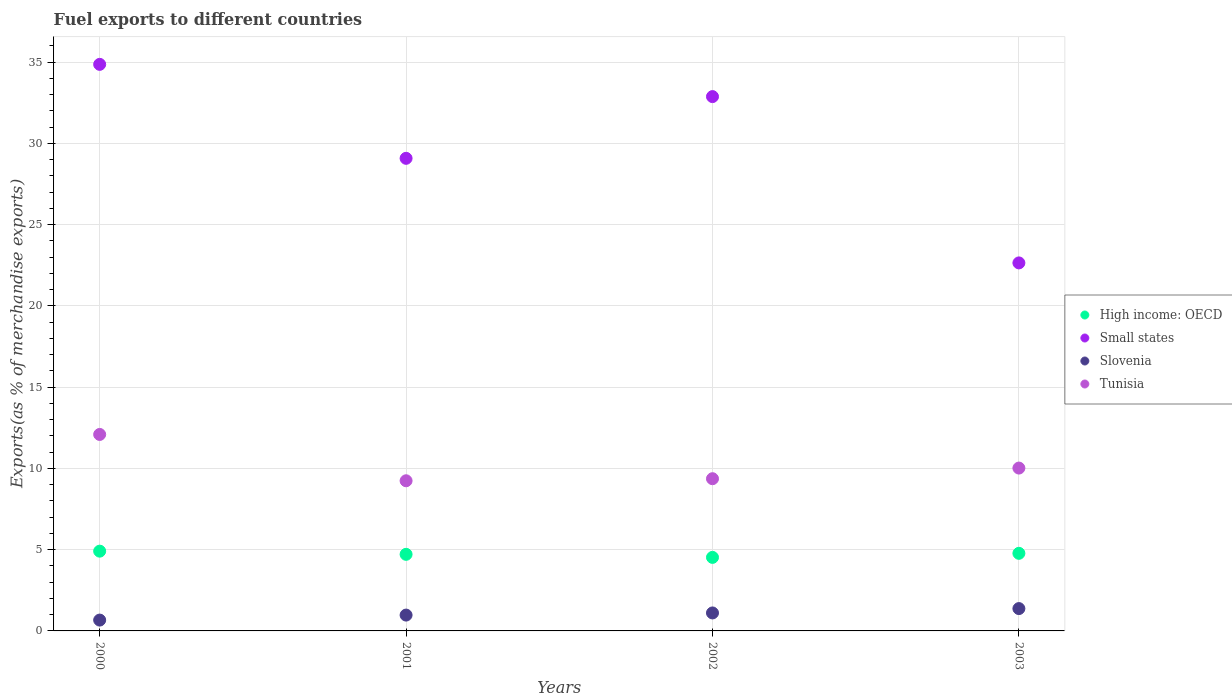Is the number of dotlines equal to the number of legend labels?
Keep it short and to the point. Yes. What is the percentage of exports to different countries in Small states in 2001?
Offer a terse response. 29.08. Across all years, what is the maximum percentage of exports to different countries in Slovenia?
Offer a very short reply. 1.37. Across all years, what is the minimum percentage of exports to different countries in High income: OECD?
Your answer should be compact. 4.52. In which year was the percentage of exports to different countries in High income: OECD maximum?
Offer a very short reply. 2000. What is the total percentage of exports to different countries in Tunisia in the graph?
Your answer should be compact. 40.71. What is the difference between the percentage of exports to different countries in High income: OECD in 2000 and that in 2002?
Ensure brevity in your answer.  0.38. What is the difference between the percentage of exports to different countries in Slovenia in 2001 and the percentage of exports to different countries in Small states in 2000?
Provide a succinct answer. -33.89. What is the average percentage of exports to different countries in Slovenia per year?
Offer a terse response. 1.03. In the year 2003, what is the difference between the percentage of exports to different countries in Tunisia and percentage of exports to different countries in Small states?
Provide a short and direct response. -12.62. What is the ratio of the percentage of exports to different countries in Tunisia in 2000 to that in 2002?
Ensure brevity in your answer.  1.29. Is the difference between the percentage of exports to different countries in Tunisia in 2000 and 2002 greater than the difference between the percentage of exports to different countries in Small states in 2000 and 2002?
Keep it short and to the point. Yes. What is the difference between the highest and the second highest percentage of exports to different countries in Tunisia?
Keep it short and to the point. 2.07. What is the difference between the highest and the lowest percentage of exports to different countries in Small states?
Ensure brevity in your answer.  12.22. In how many years, is the percentage of exports to different countries in High income: OECD greater than the average percentage of exports to different countries in High income: OECD taken over all years?
Make the answer very short. 2. Is the sum of the percentage of exports to different countries in Slovenia in 2002 and 2003 greater than the maximum percentage of exports to different countries in High income: OECD across all years?
Your answer should be very brief. No. Is it the case that in every year, the sum of the percentage of exports to different countries in Small states and percentage of exports to different countries in Tunisia  is greater than the sum of percentage of exports to different countries in High income: OECD and percentage of exports to different countries in Slovenia?
Your answer should be compact. No. Is it the case that in every year, the sum of the percentage of exports to different countries in Slovenia and percentage of exports to different countries in Tunisia  is greater than the percentage of exports to different countries in High income: OECD?
Your response must be concise. Yes. Does the percentage of exports to different countries in Small states monotonically increase over the years?
Your response must be concise. No. Is the percentage of exports to different countries in Small states strictly less than the percentage of exports to different countries in Slovenia over the years?
Make the answer very short. No. How many dotlines are there?
Provide a short and direct response. 4. How many years are there in the graph?
Make the answer very short. 4. What is the difference between two consecutive major ticks on the Y-axis?
Your response must be concise. 5. Where does the legend appear in the graph?
Keep it short and to the point. Center right. How many legend labels are there?
Offer a terse response. 4. What is the title of the graph?
Provide a succinct answer. Fuel exports to different countries. What is the label or title of the X-axis?
Your answer should be compact. Years. What is the label or title of the Y-axis?
Your answer should be very brief. Exports(as % of merchandise exports). What is the Exports(as % of merchandise exports) in High income: OECD in 2000?
Your answer should be compact. 4.91. What is the Exports(as % of merchandise exports) in Small states in 2000?
Give a very brief answer. 34.86. What is the Exports(as % of merchandise exports) of Slovenia in 2000?
Offer a very short reply. 0.67. What is the Exports(as % of merchandise exports) in Tunisia in 2000?
Make the answer very short. 12.09. What is the Exports(as % of merchandise exports) of High income: OECD in 2001?
Provide a short and direct response. 4.71. What is the Exports(as % of merchandise exports) of Small states in 2001?
Offer a terse response. 29.08. What is the Exports(as % of merchandise exports) in Slovenia in 2001?
Your answer should be very brief. 0.97. What is the Exports(as % of merchandise exports) in Tunisia in 2001?
Your response must be concise. 9.24. What is the Exports(as % of merchandise exports) in High income: OECD in 2002?
Your answer should be compact. 4.52. What is the Exports(as % of merchandise exports) of Small states in 2002?
Give a very brief answer. 32.88. What is the Exports(as % of merchandise exports) of Slovenia in 2002?
Keep it short and to the point. 1.11. What is the Exports(as % of merchandise exports) of Tunisia in 2002?
Ensure brevity in your answer.  9.36. What is the Exports(as % of merchandise exports) in High income: OECD in 2003?
Offer a very short reply. 4.77. What is the Exports(as % of merchandise exports) in Small states in 2003?
Your answer should be very brief. 22.64. What is the Exports(as % of merchandise exports) in Slovenia in 2003?
Make the answer very short. 1.37. What is the Exports(as % of merchandise exports) in Tunisia in 2003?
Your answer should be very brief. 10.02. Across all years, what is the maximum Exports(as % of merchandise exports) of High income: OECD?
Offer a very short reply. 4.91. Across all years, what is the maximum Exports(as % of merchandise exports) of Small states?
Your response must be concise. 34.86. Across all years, what is the maximum Exports(as % of merchandise exports) in Slovenia?
Your answer should be very brief. 1.37. Across all years, what is the maximum Exports(as % of merchandise exports) of Tunisia?
Provide a succinct answer. 12.09. Across all years, what is the minimum Exports(as % of merchandise exports) of High income: OECD?
Offer a very short reply. 4.52. Across all years, what is the minimum Exports(as % of merchandise exports) of Small states?
Your answer should be compact. 22.64. Across all years, what is the minimum Exports(as % of merchandise exports) of Slovenia?
Your answer should be very brief. 0.67. Across all years, what is the minimum Exports(as % of merchandise exports) of Tunisia?
Provide a succinct answer. 9.24. What is the total Exports(as % of merchandise exports) in High income: OECD in the graph?
Keep it short and to the point. 18.92. What is the total Exports(as % of merchandise exports) of Small states in the graph?
Provide a short and direct response. 119.46. What is the total Exports(as % of merchandise exports) in Slovenia in the graph?
Your answer should be compact. 4.12. What is the total Exports(as % of merchandise exports) of Tunisia in the graph?
Your response must be concise. 40.71. What is the difference between the Exports(as % of merchandise exports) of High income: OECD in 2000 and that in 2001?
Your answer should be very brief. 0.2. What is the difference between the Exports(as % of merchandise exports) in Small states in 2000 and that in 2001?
Keep it short and to the point. 5.78. What is the difference between the Exports(as % of merchandise exports) of Slovenia in 2000 and that in 2001?
Your answer should be very brief. -0.31. What is the difference between the Exports(as % of merchandise exports) of Tunisia in 2000 and that in 2001?
Your answer should be compact. 2.85. What is the difference between the Exports(as % of merchandise exports) of High income: OECD in 2000 and that in 2002?
Provide a succinct answer. 0.38. What is the difference between the Exports(as % of merchandise exports) of Small states in 2000 and that in 2002?
Your answer should be compact. 1.98. What is the difference between the Exports(as % of merchandise exports) of Slovenia in 2000 and that in 2002?
Make the answer very short. -0.44. What is the difference between the Exports(as % of merchandise exports) in Tunisia in 2000 and that in 2002?
Give a very brief answer. 2.72. What is the difference between the Exports(as % of merchandise exports) of High income: OECD in 2000 and that in 2003?
Make the answer very short. 0.13. What is the difference between the Exports(as % of merchandise exports) in Small states in 2000 and that in 2003?
Your response must be concise. 12.22. What is the difference between the Exports(as % of merchandise exports) in Slovenia in 2000 and that in 2003?
Keep it short and to the point. -0.71. What is the difference between the Exports(as % of merchandise exports) of Tunisia in 2000 and that in 2003?
Keep it short and to the point. 2.07. What is the difference between the Exports(as % of merchandise exports) in High income: OECD in 2001 and that in 2002?
Ensure brevity in your answer.  0.19. What is the difference between the Exports(as % of merchandise exports) in Small states in 2001 and that in 2002?
Offer a terse response. -3.8. What is the difference between the Exports(as % of merchandise exports) in Slovenia in 2001 and that in 2002?
Make the answer very short. -0.13. What is the difference between the Exports(as % of merchandise exports) of Tunisia in 2001 and that in 2002?
Your response must be concise. -0.13. What is the difference between the Exports(as % of merchandise exports) of High income: OECD in 2001 and that in 2003?
Offer a terse response. -0.06. What is the difference between the Exports(as % of merchandise exports) of Small states in 2001 and that in 2003?
Your answer should be very brief. 6.43. What is the difference between the Exports(as % of merchandise exports) in Slovenia in 2001 and that in 2003?
Keep it short and to the point. -0.4. What is the difference between the Exports(as % of merchandise exports) of Tunisia in 2001 and that in 2003?
Keep it short and to the point. -0.78. What is the difference between the Exports(as % of merchandise exports) of High income: OECD in 2002 and that in 2003?
Your answer should be compact. -0.25. What is the difference between the Exports(as % of merchandise exports) of Small states in 2002 and that in 2003?
Offer a very short reply. 10.23. What is the difference between the Exports(as % of merchandise exports) of Slovenia in 2002 and that in 2003?
Your response must be concise. -0.27. What is the difference between the Exports(as % of merchandise exports) of Tunisia in 2002 and that in 2003?
Give a very brief answer. -0.65. What is the difference between the Exports(as % of merchandise exports) in High income: OECD in 2000 and the Exports(as % of merchandise exports) in Small states in 2001?
Provide a short and direct response. -24.17. What is the difference between the Exports(as % of merchandise exports) in High income: OECD in 2000 and the Exports(as % of merchandise exports) in Slovenia in 2001?
Your answer should be very brief. 3.93. What is the difference between the Exports(as % of merchandise exports) in High income: OECD in 2000 and the Exports(as % of merchandise exports) in Tunisia in 2001?
Offer a very short reply. -4.33. What is the difference between the Exports(as % of merchandise exports) in Small states in 2000 and the Exports(as % of merchandise exports) in Slovenia in 2001?
Offer a very short reply. 33.89. What is the difference between the Exports(as % of merchandise exports) of Small states in 2000 and the Exports(as % of merchandise exports) of Tunisia in 2001?
Offer a very short reply. 25.62. What is the difference between the Exports(as % of merchandise exports) of Slovenia in 2000 and the Exports(as % of merchandise exports) of Tunisia in 2001?
Offer a very short reply. -8.57. What is the difference between the Exports(as % of merchandise exports) in High income: OECD in 2000 and the Exports(as % of merchandise exports) in Small states in 2002?
Give a very brief answer. -27.97. What is the difference between the Exports(as % of merchandise exports) in High income: OECD in 2000 and the Exports(as % of merchandise exports) in Slovenia in 2002?
Keep it short and to the point. 3.8. What is the difference between the Exports(as % of merchandise exports) in High income: OECD in 2000 and the Exports(as % of merchandise exports) in Tunisia in 2002?
Provide a succinct answer. -4.46. What is the difference between the Exports(as % of merchandise exports) in Small states in 2000 and the Exports(as % of merchandise exports) in Slovenia in 2002?
Your response must be concise. 33.75. What is the difference between the Exports(as % of merchandise exports) of Small states in 2000 and the Exports(as % of merchandise exports) of Tunisia in 2002?
Make the answer very short. 25.49. What is the difference between the Exports(as % of merchandise exports) of Slovenia in 2000 and the Exports(as % of merchandise exports) of Tunisia in 2002?
Offer a very short reply. -8.7. What is the difference between the Exports(as % of merchandise exports) of High income: OECD in 2000 and the Exports(as % of merchandise exports) of Small states in 2003?
Give a very brief answer. -17.74. What is the difference between the Exports(as % of merchandise exports) in High income: OECD in 2000 and the Exports(as % of merchandise exports) in Slovenia in 2003?
Keep it short and to the point. 3.53. What is the difference between the Exports(as % of merchandise exports) in High income: OECD in 2000 and the Exports(as % of merchandise exports) in Tunisia in 2003?
Ensure brevity in your answer.  -5.11. What is the difference between the Exports(as % of merchandise exports) in Small states in 2000 and the Exports(as % of merchandise exports) in Slovenia in 2003?
Make the answer very short. 33.48. What is the difference between the Exports(as % of merchandise exports) of Small states in 2000 and the Exports(as % of merchandise exports) of Tunisia in 2003?
Give a very brief answer. 24.84. What is the difference between the Exports(as % of merchandise exports) of Slovenia in 2000 and the Exports(as % of merchandise exports) of Tunisia in 2003?
Your answer should be very brief. -9.35. What is the difference between the Exports(as % of merchandise exports) of High income: OECD in 2001 and the Exports(as % of merchandise exports) of Small states in 2002?
Make the answer very short. -28.16. What is the difference between the Exports(as % of merchandise exports) of High income: OECD in 2001 and the Exports(as % of merchandise exports) of Slovenia in 2002?
Ensure brevity in your answer.  3.61. What is the difference between the Exports(as % of merchandise exports) of High income: OECD in 2001 and the Exports(as % of merchandise exports) of Tunisia in 2002?
Ensure brevity in your answer.  -4.65. What is the difference between the Exports(as % of merchandise exports) of Small states in 2001 and the Exports(as % of merchandise exports) of Slovenia in 2002?
Your answer should be very brief. 27.97. What is the difference between the Exports(as % of merchandise exports) of Small states in 2001 and the Exports(as % of merchandise exports) of Tunisia in 2002?
Your answer should be very brief. 19.71. What is the difference between the Exports(as % of merchandise exports) of Slovenia in 2001 and the Exports(as % of merchandise exports) of Tunisia in 2002?
Provide a succinct answer. -8.39. What is the difference between the Exports(as % of merchandise exports) of High income: OECD in 2001 and the Exports(as % of merchandise exports) of Small states in 2003?
Offer a terse response. -17.93. What is the difference between the Exports(as % of merchandise exports) of High income: OECD in 2001 and the Exports(as % of merchandise exports) of Slovenia in 2003?
Ensure brevity in your answer.  3.34. What is the difference between the Exports(as % of merchandise exports) in High income: OECD in 2001 and the Exports(as % of merchandise exports) in Tunisia in 2003?
Make the answer very short. -5.31. What is the difference between the Exports(as % of merchandise exports) in Small states in 2001 and the Exports(as % of merchandise exports) in Slovenia in 2003?
Provide a short and direct response. 27.7. What is the difference between the Exports(as % of merchandise exports) of Small states in 2001 and the Exports(as % of merchandise exports) of Tunisia in 2003?
Make the answer very short. 19.06. What is the difference between the Exports(as % of merchandise exports) of Slovenia in 2001 and the Exports(as % of merchandise exports) of Tunisia in 2003?
Ensure brevity in your answer.  -9.05. What is the difference between the Exports(as % of merchandise exports) in High income: OECD in 2002 and the Exports(as % of merchandise exports) in Small states in 2003?
Give a very brief answer. -18.12. What is the difference between the Exports(as % of merchandise exports) of High income: OECD in 2002 and the Exports(as % of merchandise exports) of Slovenia in 2003?
Your answer should be compact. 3.15. What is the difference between the Exports(as % of merchandise exports) of High income: OECD in 2002 and the Exports(as % of merchandise exports) of Tunisia in 2003?
Your answer should be compact. -5.5. What is the difference between the Exports(as % of merchandise exports) in Small states in 2002 and the Exports(as % of merchandise exports) in Slovenia in 2003?
Your response must be concise. 31.5. What is the difference between the Exports(as % of merchandise exports) in Small states in 2002 and the Exports(as % of merchandise exports) in Tunisia in 2003?
Your answer should be very brief. 22.86. What is the difference between the Exports(as % of merchandise exports) in Slovenia in 2002 and the Exports(as % of merchandise exports) in Tunisia in 2003?
Offer a terse response. -8.91. What is the average Exports(as % of merchandise exports) in High income: OECD per year?
Your answer should be very brief. 4.73. What is the average Exports(as % of merchandise exports) of Small states per year?
Your answer should be compact. 29.86. What is the average Exports(as % of merchandise exports) in Slovenia per year?
Give a very brief answer. 1.03. What is the average Exports(as % of merchandise exports) of Tunisia per year?
Offer a very short reply. 10.18. In the year 2000, what is the difference between the Exports(as % of merchandise exports) of High income: OECD and Exports(as % of merchandise exports) of Small states?
Give a very brief answer. -29.95. In the year 2000, what is the difference between the Exports(as % of merchandise exports) in High income: OECD and Exports(as % of merchandise exports) in Slovenia?
Make the answer very short. 4.24. In the year 2000, what is the difference between the Exports(as % of merchandise exports) of High income: OECD and Exports(as % of merchandise exports) of Tunisia?
Make the answer very short. -7.18. In the year 2000, what is the difference between the Exports(as % of merchandise exports) in Small states and Exports(as % of merchandise exports) in Slovenia?
Keep it short and to the point. 34.19. In the year 2000, what is the difference between the Exports(as % of merchandise exports) of Small states and Exports(as % of merchandise exports) of Tunisia?
Your answer should be compact. 22.77. In the year 2000, what is the difference between the Exports(as % of merchandise exports) of Slovenia and Exports(as % of merchandise exports) of Tunisia?
Provide a short and direct response. -11.42. In the year 2001, what is the difference between the Exports(as % of merchandise exports) of High income: OECD and Exports(as % of merchandise exports) of Small states?
Your answer should be very brief. -24.37. In the year 2001, what is the difference between the Exports(as % of merchandise exports) of High income: OECD and Exports(as % of merchandise exports) of Slovenia?
Provide a short and direct response. 3.74. In the year 2001, what is the difference between the Exports(as % of merchandise exports) of High income: OECD and Exports(as % of merchandise exports) of Tunisia?
Your answer should be very brief. -4.53. In the year 2001, what is the difference between the Exports(as % of merchandise exports) of Small states and Exports(as % of merchandise exports) of Slovenia?
Offer a terse response. 28.1. In the year 2001, what is the difference between the Exports(as % of merchandise exports) of Small states and Exports(as % of merchandise exports) of Tunisia?
Provide a succinct answer. 19.84. In the year 2001, what is the difference between the Exports(as % of merchandise exports) in Slovenia and Exports(as % of merchandise exports) in Tunisia?
Make the answer very short. -8.26. In the year 2002, what is the difference between the Exports(as % of merchandise exports) of High income: OECD and Exports(as % of merchandise exports) of Small states?
Your answer should be compact. -28.35. In the year 2002, what is the difference between the Exports(as % of merchandise exports) of High income: OECD and Exports(as % of merchandise exports) of Slovenia?
Keep it short and to the point. 3.42. In the year 2002, what is the difference between the Exports(as % of merchandise exports) in High income: OECD and Exports(as % of merchandise exports) in Tunisia?
Offer a very short reply. -4.84. In the year 2002, what is the difference between the Exports(as % of merchandise exports) of Small states and Exports(as % of merchandise exports) of Slovenia?
Provide a short and direct response. 31.77. In the year 2002, what is the difference between the Exports(as % of merchandise exports) of Small states and Exports(as % of merchandise exports) of Tunisia?
Your answer should be compact. 23.51. In the year 2002, what is the difference between the Exports(as % of merchandise exports) of Slovenia and Exports(as % of merchandise exports) of Tunisia?
Provide a succinct answer. -8.26. In the year 2003, what is the difference between the Exports(as % of merchandise exports) of High income: OECD and Exports(as % of merchandise exports) of Small states?
Your answer should be compact. -17.87. In the year 2003, what is the difference between the Exports(as % of merchandise exports) in High income: OECD and Exports(as % of merchandise exports) in Slovenia?
Give a very brief answer. 3.4. In the year 2003, what is the difference between the Exports(as % of merchandise exports) in High income: OECD and Exports(as % of merchandise exports) in Tunisia?
Make the answer very short. -5.25. In the year 2003, what is the difference between the Exports(as % of merchandise exports) in Small states and Exports(as % of merchandise exports) in Slovenia?
Offer a very short reply. 21.27. In the year 2003, what is the difference between the Exports(as % of merchandise exports) of Small states and Exports(as % of merchandise exports) of Tunisia?
Keep it short and to the point. 12.62. In the year 2003, what is the difference between the Exports(as % of merchandise exports) in Slovenia and Exports(as % of merchandise exports) in Tunisia?
Offer a very short reply. -8.65. What is the ratio of the Exports(as % of merchandise exports) of High income: OECD in 2000 to that in 2001?
Your response must be concise. 1.04. What is the ratio of the Exports(as % of merchandise exports) of Small states in 2000 to that in 2001?
Provide a short and direct response. 1.2. What is the ratio of the Exports(as % of merchandise exports) of Slovenia in 2000 to that in 2001?
Provide a succinct answer. 0.68. What is the ratio of the Exports(as % of merchandise exports) of Tunisia in 2000 to that in 2001?
Your answer should be very brief. 1.31. What is the ratio of the Exports(as % of merchandise exports) in High income: OECD in 2000 to that in 2002?
Provide a succinct answer. 1.08. What is the ratio of the Exports(as % of merchandise exports) in Small states in 2000 to that in 2002?
Offer a terse response. 1.06. What is the ratio of the Exports(as % of merchandise exports) of Slovenia in 2000 to that in 2002?
Offer a very short reply. 0.6. What is the ratio of the Exports(as % of merchandise exports) in Tunisia in 2000 to that in 2002?
Provide a succinct answer. 1.29. What is the ratio of the Exports(as % of merchandise exports) of High income: OECD in 2000 to that in 2003?
Offer a very short reply. 1.03. What is the ratio of the Exports(as % of merchandise exports) in Small states in 2000 to that in 2003?
Your answer should be compact. 1.54. What is the ratio of the Exports(as % of merchandise exports) in Slovenia in 2000 to that in 2003?
Offer a terse response. 0.49. What is the ratio of the Exports(as % of merchandise exports) of Tunisia in 2000 to that in 2003?
Your answer should be very brief. 1.21. What is the ratio of the Exports(as % of merchandise exports) of High income: OECD in 2001 to that in 2002?
Keep it short and to the point. 1.04. What is the ratio of the Exports(as % of merchandise exports) in Small states in 2001 to that in 2002?
Give a very brief answer. 0.88. What is the ratio of the Exports(as % of merchandise exports) in Slovenia in 2001 to that in 2002?
Ensure brevity in your answer.  0.88. What is the ratio of the Exports(as % of merchandise exports) in Tunisia in 2001 to that in 2002?
Offer a terse response. 0.99. What is the ratio of the Exports(as % of merchandise exports) in High income: OECD in 2001 to that in 2003?
Your answer should be very brief. 0.99. What is the ratio of the Exports(as % of merchandise exports) in Small states in 2001 to that in 2003?
Ensure brevity in your answer.  1.28. What is the ratio of the Exports(as % of merchandise exports) in Slovenia in 2001 to that in 2003?
Give a very brief answer. 0.71. What is the ratio of the Exports(as % of merchandise exports) of Tunisia in 2001 to that in 2003?
Offer a terse response. 0.92. What is the ratio of the Exports(as % of merchandise exports) of High income: OECD in 2002 to that in 2003?
Ensure brevity in your answer.  0.95. What is the ratio of the Exports(as % of merchandise exports) of Small states in 2002 to that in 2003?
Ensure brevity in your answer.  1.45. What is the ratio of the Exports(as % of merchandise exports) of Slovenia in 2002 to that in 2003?
Your response must be concise. 0.8. What is the ratio of the Exports(as % of merchandise exports) of Tunisia in 2002 to that in 2003?
Your response must be concise. 0.93. What is the difference between the highest and the second highest Exports(as % of merchandise exports) in High income: OECD?
Your response must be concise. 0.13. What is the difference between the highest and the second highest Exports(as % of merchandise exports) in Small states?
Provide a succinct answer. 1.98. What is the difference between the highest and the second highest Exports(as % of merchandise exports) in Slovenia?
Ensure brevity in your answer.  0.27. What is the difference between the highest and the second highest Exports(as % of merchandise exports) in Tunisia?
Offer a very short reply. 2.07. What is the difference between the highest and the lowest Exports(as % of merchandise exports) of High income: OECD?
Give a very brief answer. 0.38. What is the difference between the highest and the lowest Exports(as % of merchandise exports) in Small states?
Your answer should be very brief. 12.22. What is the difference between the highest and the lowest Exports(as % of merchandise exports) in Slovenia?
Provide a succinct answer. 0.71. What is the difference between the highest and the lowest Exports(as % of merchandise exports) of Tunisia?
Make the answer very short. 2.85. 